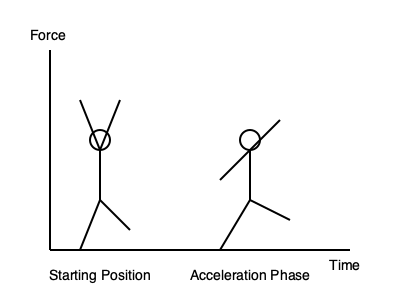Analyze the stick figure diagrams representing sprint mechanics during acceleration. Which key aspect of body positioning in the acceleration phase (Figure 2) contributes most significantly to generating forward propulsion and improving initial acceleration? To answer this question, let's analyze the body positioning in both figures, focusing on the acceleration phase (Figure 2):

1. Starting position (Figure 1):
   - Body is more upright
   - Arms are at 90-degree angles
   - Legs are relatively straight

2. Acceleration phase (Figure 2):
   - Body is leaning forward
   - Arms are in a more dynamic position
   - Legs show a more powerful stance

The key differences in the acceleration phase are:

a) Forward lean: The body is angled forward, which helps to overcome inertia and create a falling motion.

b) Arm position: Arms are in a more extreme position, with one arm forward and high, the other back and low, creating a counterbalance to leg movement.

c) Leg drive: The back leg is fully extended, pushing against the ground, while the front leg is bent and driving forward.

The most significant aspect for generating forward propulsion is the forward lean of the body. This forward lean:

1. Shifts the center of gravity ahead of the base of support
2. Creates a "controlled fall" forward
3. Allows for more effective application of force against the ground
4. Reduces wind resistance by presenting a smaller frontal area

The forward lean works in conjunction with powerful leg drive and arm action, but it is the primary factor that enables the athlete to overcome inertia and accelerate quickly. This position allows for optimal force application in the horizontal direction, which is crucial for acceleration in sprinting.
Answer: Forward lean of the body 